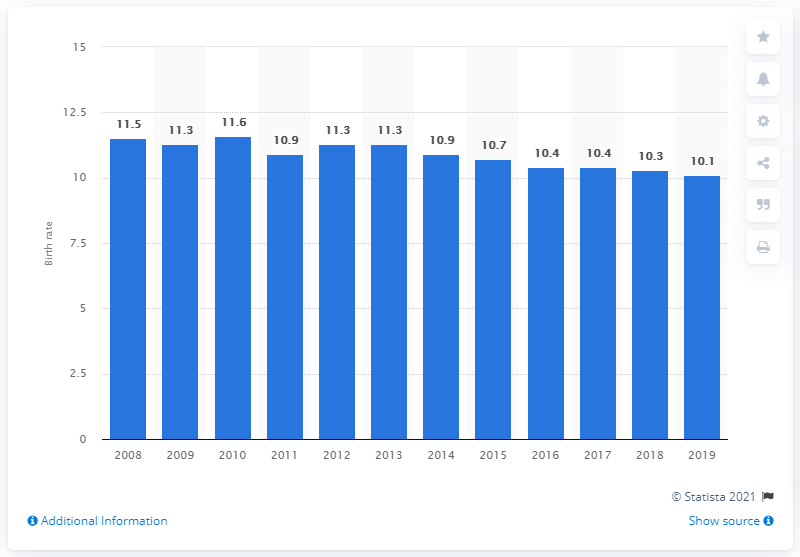Mention a couple of crucial points in this snapshot. According to data from 2019, the birth rate in Luxembourg was 10.1. 